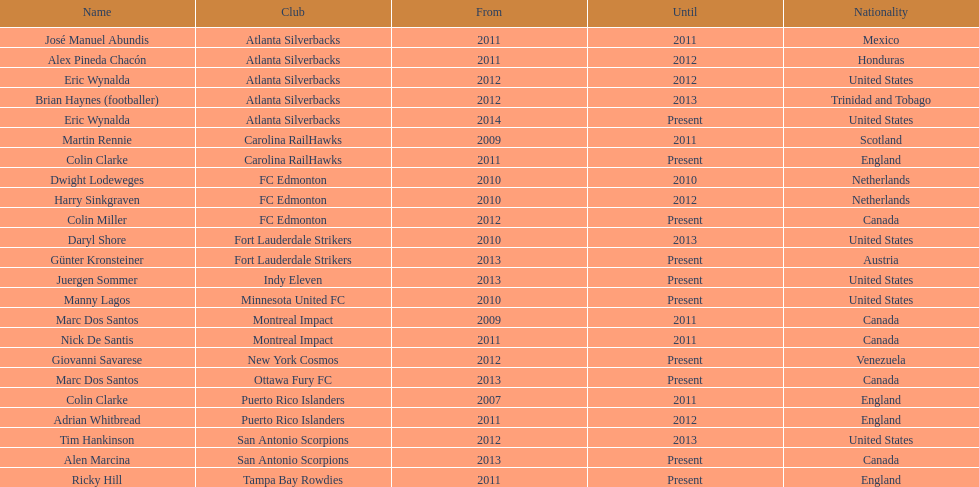How long did colin clarke coach the puerto rico islanders? 4 years. Could you parse the entire table? {'header': ['Name', 'Club', 'From', 'Until', 'Nationality'], 'rows': [['José Manuel Abundis', 'Atlanta Silverbacks', '2011', '2011', 'Mexico'], ['Alex Pineda Chacón', 'Atlanta Silverbacks', '2011', '2012', 'Honduras'], ['Eric Wynalda', 'Atlanta Silverbacks', '2012', '2012', 'United States'], ['Brian Haynes (footballer)', 'Atlanta Silverbacks', '2012', '2013', 'Trinidad and Tobago'], ['Eric Wynalda', 'Atlanta Silverbacks', '2014', 'Present', 'United States'], ['Martin Rennie', 'Carolina RailHawks', '2009', '2011', 'Scotland'], ['Colin Clarke', 'Carolina RailHawks', '2011', 'Present', 'England'], ['Dwight Lodeweges', 'FC Edmonton', '2010', '2010', 'Netherlands'], ['Harry Sinkgraven', 'FC Edmonton', '2010', '2012', 'Netherlands'], ['Colin Miller', 'FC Edmonton', '2012', 'Present', 'Canada'], ['Daryl Shore', 'Fort Lauderdale Strikers', '2010', '2013', 'United States'], ['Günter Kronsteiner', 'Fort Lauderdale Strikers', '2013', 'Present', 'Austria'], ['Juergen Sommer', 'Indy Eleven', '2013', 'Present', 'United States'], ['Manny Lagos', 'Minnesota United FC', '2010', 'Present', 'United States'], ['Marc Dos Santos', 'Montreal Impact', '2009', '2011', 'Canada'], ['Nick De Santis', 'Montreal Impact', '2011', '2011', 'Canada'], ['Giovanni Savarese', 'New York Cosmos', '2012', 'Present', 'Venezuela'], ['Marc Dos Santos', 'Ottawa Fury FC', '2013', 'Present', 'Canada'], ['Colin Clarke', 'Puerto Rico Islanders', '2007', '2011', 'England'], ['Adrian Whitbread', 'Puerto Rico Islanders', '2011', '2012', 'England'], ['Tim Hankinson', 'San Antonio Scorpions', '2012', '2013', 'United States'], ['Alen Marcina', 'San Antonio Scorpions', '2013', 'Present', 'Canada'], ['Ricky Hill', 'Tampa Bay Rowdies', '2011', 'Present', 'England']]} 